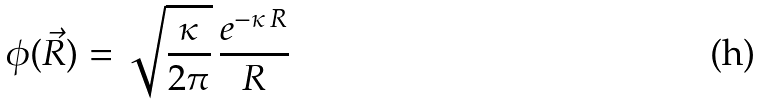Convert formula to latex. <formula><loc_0><loc_0><loc_500><loc_500>\phi ( \vec { R } ) = \sqrt { \frac { \kappa } { 2 \pi } } \, \frac { e ^ { - \kappa \, R } } { R }</formula> 